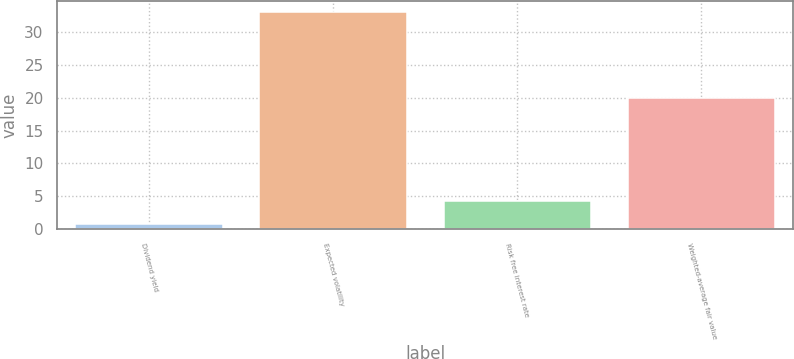Convert chart. <chart><loc_0><loc_0><loc_500><loc_500><bar_chart><fcel>Dividend yield<fcel>Expected volatility<fcel>Risk free interest rate<fcel>Weighted-average fair value<nl><fcel>0.8<fcel>33<fcel>4.3<fcel>20.03<nl></chart> 